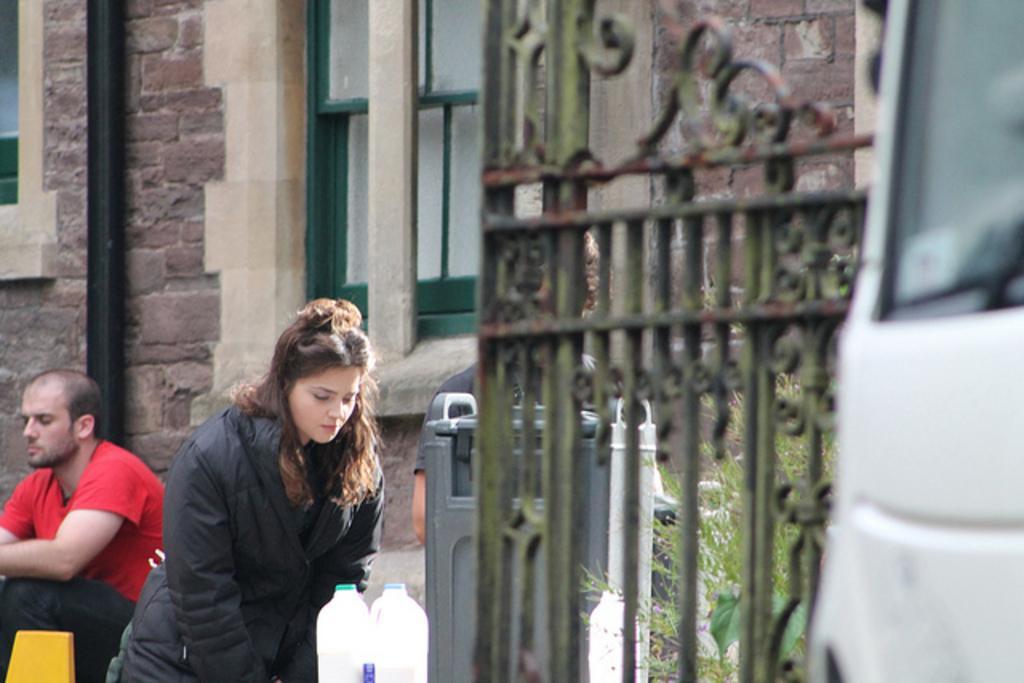Could you give a brief overview of what you see in this image? In this picture we can see two persons, one women and one man, in front we can see a dustbin and two bottles, on right side of the image we can see a gate, in the background there is a brick wall and a pipe and behind the pipe we can see a window. 